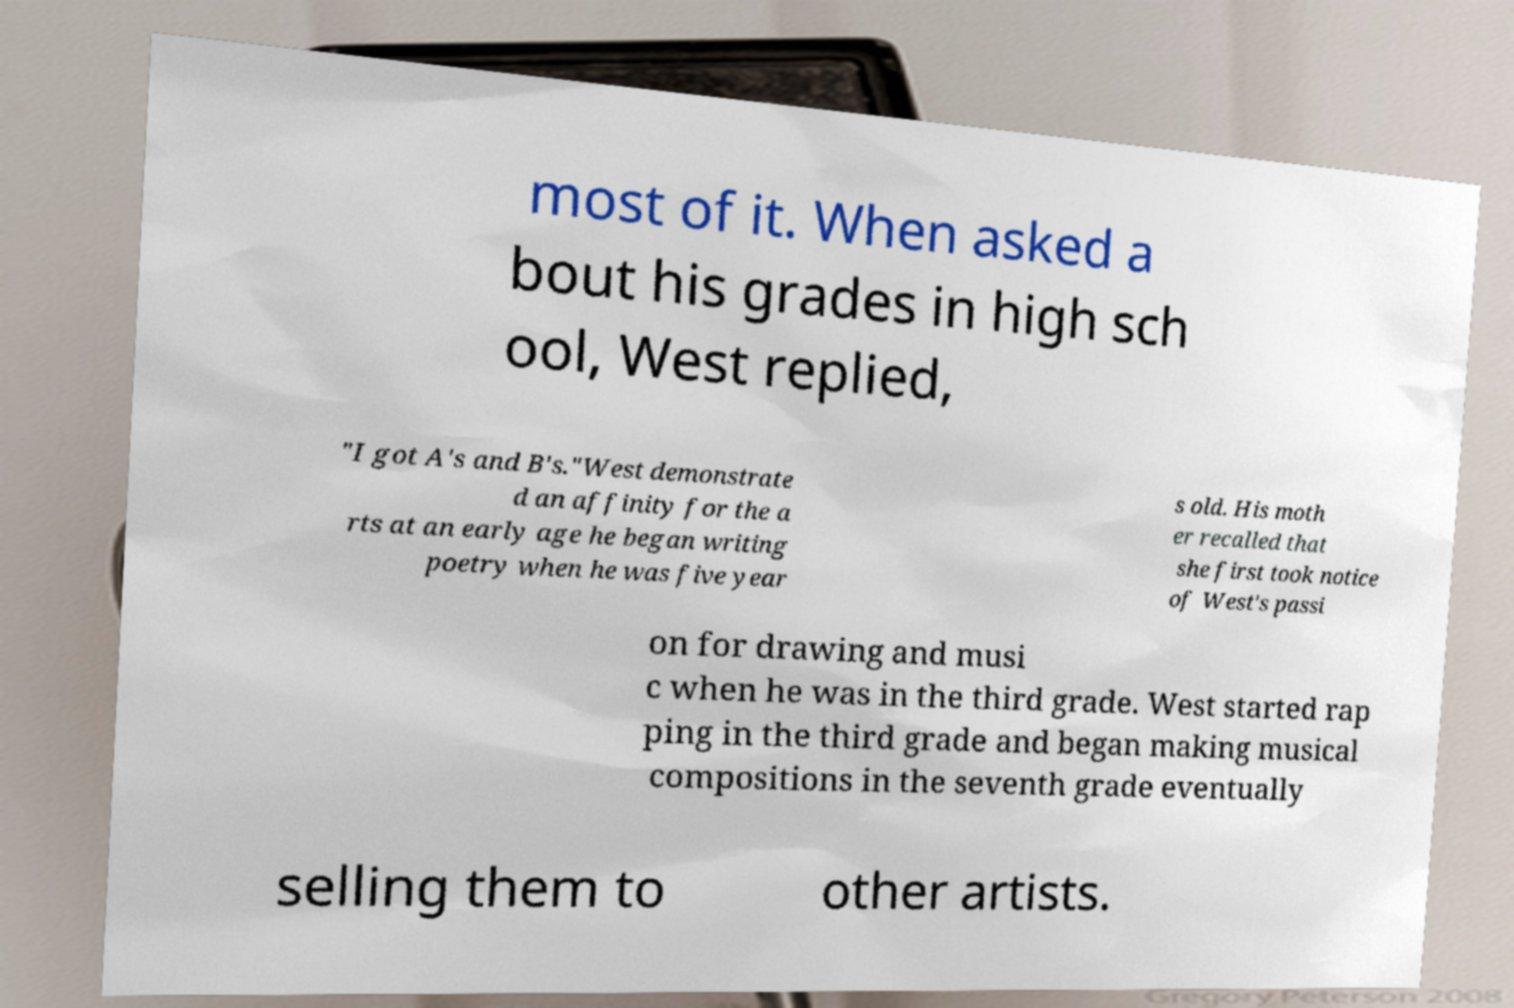For documentation purposes, I need the text within this image transcribed. Could you provide that? most of it. When asked a bout his grades in high sch ool, West replied, "I got A's and B's."West demonstrate d an affinity for the a rts at an early age he began writing poetry when he was five year s old. His moth er recalled that she first took notice of West's passi on for drawing and musi c when he was in the third grade. West started rap ping in the third grade and began making musical compositions in the seventh grade eventually selling them to other artists. 